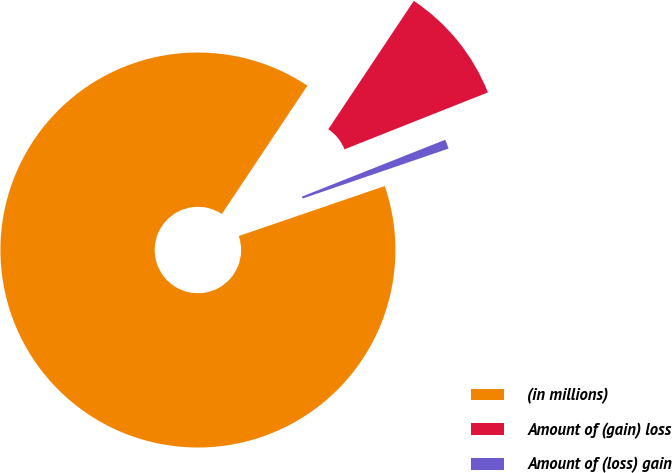Convert chart. <chart><loc_0><loc_0><loc_500><loc_500><pie_chart><fcel>(in millions)<fcel>Amount of (gain) loss<fcel>Amount of (loss) gain<nl><fcel>89.6%<fcel>9.64%<fcel>0.76%<nl></chart> 